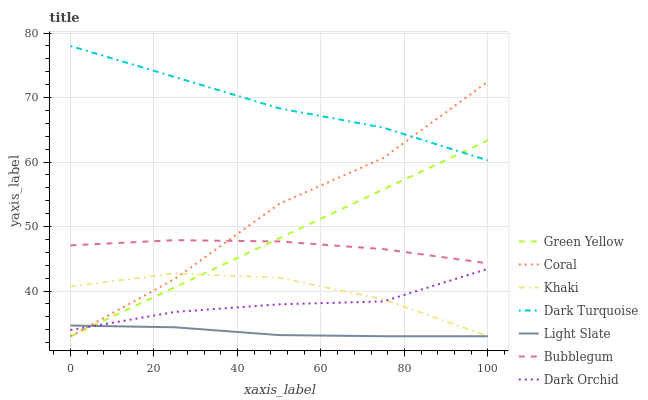Does Light Slate have the minimum area under the curve?
Answer yes or no. Yes. Does Dark Turquoise have the maximum area under the curve?
Answer yes or no. Yes. Does Dark Turquoise have the minimum area under the curve?
Answer yes or no. No. Does Light Slate have the maximum area under the curve?
Answer yes or no. No. Is Green Yellow the smoothest?
Answer yes or no. Yes. Is Coral the roughest?
Answer yes or no. Yes. Is Light Slate the smoothest?
Answer yes or no. No. Is Light Slate the roughest?
Answer yes or no. No. Does Khaki have the lowest value?
Answer yes or no. Yes. Does Dark Turquoise have the lowest value?
Answer yes or no. No. Does Dark Turquoise have the highest value?
Answer yes or no. Yes. Does Light Slate have the highest value?
Answer yes or no. No. Is Dark Orchid less than Dark Turquoise?
Answer yes or no. Yes. Is Bubblegum greater than Khaki?
Answer yes or no. Yes. Does Light Slate intersect Green Yellow?
Answer yes or no. Yes. Is Light Slate less than Green Yellow?
Answer yes or no. No. Is Light Slate greater than Green Yellow?
Answer yes or no. No. Does Dark Orchid intersect Dark Turquoise?
Answer yes or no. No. 